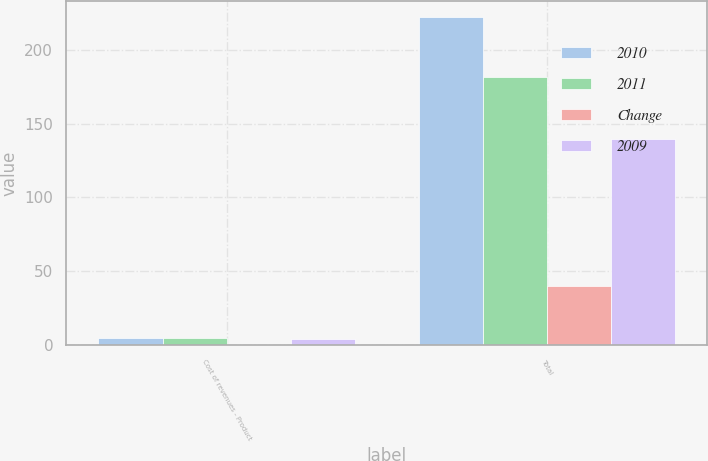<chart> <loc_0><loc_0><loc_500><loc_500><stacked_bar_chart><ecel><fcel>Cost of revenues - Product<fcel>Total<nl><fcel>2010<fcel>4.6<fcel>222.2<nl><fcel>2011<fcel>4.4<fcel>182<nl><fcel>Change<fcel>0.2<fcel>40.2<nl><fcel>2009<fcel>3.9<fcel>139.7<nl></chart> 